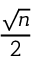Convert formula to latex. <formula><loc_0><loc_0><loc_500><loc_500>\frac { \sqrt { n } } { 2 }</formula> 